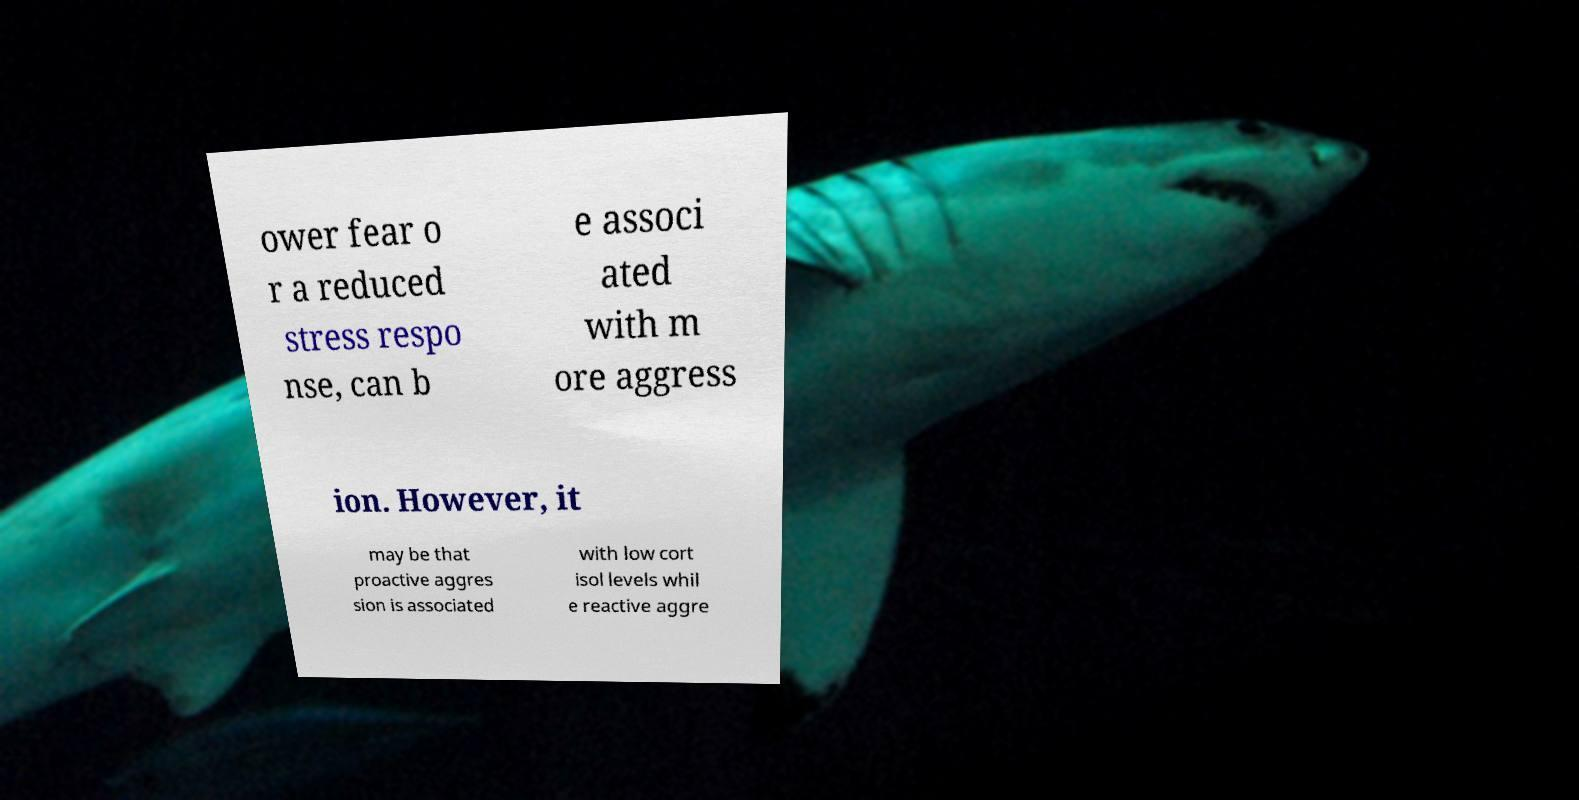Could you assist in decoding the text presented in this image and type it out clearly? ower fear o r a reduced stress respo nse, can b e associ ated with m ore aggress ion. However, it may be that proactive aggres sion is associated with low cort isol levels whil e reactive aggre 